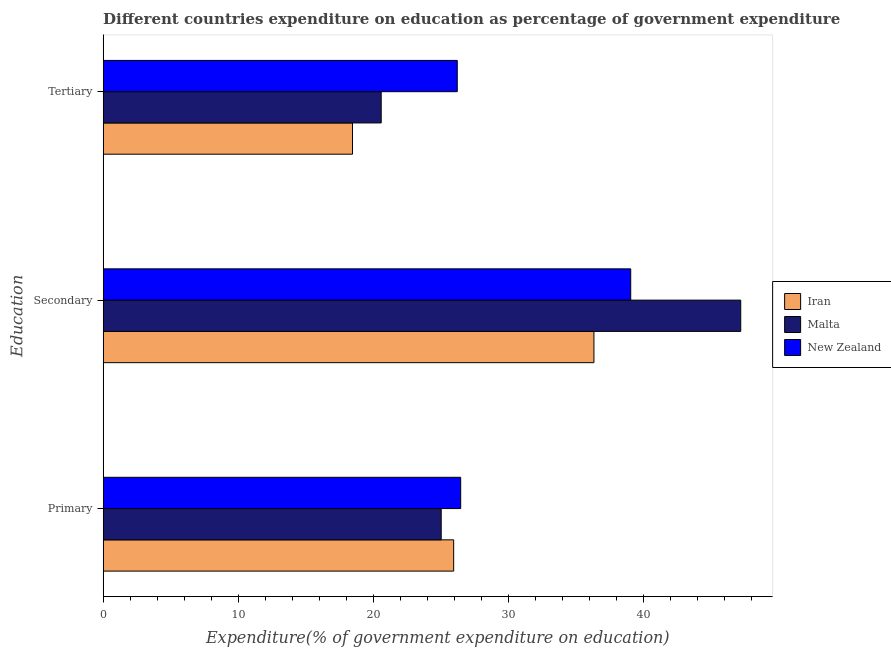How many different coloured bars are there?
Keep it short and to the point. 3. Are the number of bars on each tick of the Y-axis equal?
Your response must be concise. Yes. How many bars are there on the 2nd tick from the bottom?
Keep it short and to the point. 3. What is the label of the 3rd group of bars from the top?
Ensure brevity in your answer.  Primary. What is the expenditure on tertiary education in New Zealand?
Ensure brevity in your answer.  26.21. Across all countries, what is the maximum expenditure on primary education?
Provide a succinct answer. 26.47. Across all countries, what is the minimum expenditure on tertiary education?
Ensure brevity in your answer.  18.46. In which country was the expenditure on tertiary education maximum?
Make the answer very short. New Zealand. In which country was the expenditure on secondary education minimum?
Provide a succinct answer. Iran. What is the total expenditure on secondary education in the graph?
Your answer should be compact. 122.58. What is the difference between the expenditure on primary education in Malta and that in New Zealand?
Provide a succinct answer. -1.44. What is the difference between the expenditure on secondary education in New Zealand and the expenditure on primary education in Iran?
Offer a terse response. 13.11. What is the average expenditure on primary education per country?
Your response must be concise. 25.81. What is the difference between the expenditure on tertiary education and expenditure on primary education in New Zealand?
Provide a succinct answer. -0.25. In how many countries, is the expenditure on tertiary education greater than 14 %?
Give a very brief answer. 3. What is the ratio of the expenditure on primary education in Iran to that in New Zealand?
Your answer should be compact. 0.98. Is the expenditure on secondary education in New Zealand less than that in Iran?
Provide a short and direct response. No. Is the difference between the expenditure on tertiary education in Malta and New Zealand greater than the difference between the expenditure on primary education in Malta and New Zealand?
Your answer should be very brief. No. What is the difference between the highest and the second highest expenditure on secondary education?
Your response must be concise. 8.14. What is the difference between the highest and the lowest expenditure on tertiary education?
Ensure brevity in your answer.  7.76. Is the sum of the expenditure on tertiary education in Malta and Iran greater than the maximum expenditure on secondary education across all countries?
Make the answer very short. No. What does the 2nd bar from the top in Tertiary represents?
Your answer should be very brief. Malta. What does the 1st bar from the bottom in Secondary represents?
Ensure brevity in your answer.  Iran. How many bars are there?
Your response must be concise. 9. Are the values on the major ticks of X-axis written in scientific E-notation?
Make the answer very short. No. Does the graph contain any zero values?
Make the answer very short. No. Where does the legend appear in the graph?
Provide a short and direct response. Center right. What is the title of the graph?
Provide a succinct answer. Different countries expenditure on education as percentage of government expenditure. What is the label or title of the X-axis?
Ensure brevity in your answer.  Expenditure(% of government expenditure on education). What is the label or title of the Y-axis?
Your response must be concise. Education. What is the Expenditure(% of government expenditure on education) in Iran in Primary?
Provide a short and direct response. 25.95. What is the Expenditure(% of government expenditure on education) of Malta in Primary?
Ensure brevity in your answer.  25.02. What is the Expenditure(% of government expenditure on education) of New Zealand in Primary?
Your answer should be compact. 26.47. What is the Expenditure(% of government expenditure on education) in Iran in Secondary?
Offer a terse response. 36.33. What is the Expenditure(% of government expenditure on education) in Malta in Secondary?
Offer a very short reply. 47.2. What is the Expenditure(% of government expenditure on education) in New Zealand in Secondary?
Give a very brief answer. 39.05. What is the Expenditure(% of government expenditure on education) in Iran in Tertiary?
Ensure brevity in your answer.  18.46. What is the Expenditure(% of government expenditure on education) of Malta in Tertiary?
Provide a succinct answer. 20.58. What is the Expenditure(% of government expenditure on education) of New Zealand in Tertiary?
Your answer should be compact. 26.21. Across all Education, what is the maximum Expenditure(% of government expenditure on education) in Iran?
Provide a succinct answer. 36.33. Across all Education, what is the maximum Expenditure(% of government expenditure on education) in Malta?
Ensure brevity in your answer.  47.2. Across all Education, what is the maximum Expenditure(% of government expenditure on education) of New Zealand?
Give a very brief answer. 39.05. Across all Education, what is the minimum Expenditure(% of government expenditure on education) of Iran?
Give a very brief answer. 18.46. Across all Education, what is the minimum Expenditure(% of government expenditure on education) of Malta?
Make the answer very short. 20.58. Across all Education, what is the minimum Expenditure(% of government expenditure on education) of New Zealand?
Provide a short and direct response. 26.21. What is the total Expenditure(% of government expenditure on education) of Iran in the graph?
Offer a very short reply. 80.73. What is the total Expenditure(% of government expenditure on education) in Malta in the graph?
Provide a succinct answer. 92.8. What is the total Expenditure(% of government expenditure on education) of New Zealand in the graph?
Your answer should be very brief. 91.73. What is the difference between the Expenditure(% of government expenditure on education) in Iran in Primary and that in Secondary?
Provide a short and direct response. -10.38. What is the difference between the Expenditure(% of government expenditure on education) of Malta in Primary and that in Secondary?
Provide a short and direct response. -22.17. What is the difference between the Expenditure(% of government expenditure on education) in New Zealand in Primary and that in Secondary?
Make the answer very short. -12.59. What is the difference between the Expenditure(% of government expenditure on education) in Iran in Primary and that in Tertiary?
Make the answer very short. 7.49. What is the difference between the Expenditure(% of government expenditure on education) of Malta in Primary and that in Tertiary?
Your answer should be compact. 4.44. What is the difference between the Expenditure(% of government expenditure on education) in New Zealand in Primary and that in Tertiary?
Your response must be concise. 0.25. What is the difference between the Expenditure(% of government expenditure on education) of Iran in Secondary and that in Tertiary?
Your response must be concise. 17.87. What is the difference between the Expenditure(% of government expenditure on education) in Malta in Secondary and that in Tertiary?
Your answer should be compact. 26.61. What is the difference between the Expenditure(% of government expenditure on education) of New Zealand in Secondary and that in Tertiary?
Provide a succinct answer. 12.84. What is the difference between the Expenditure(% of government expenditure on education) of Iran in Primary and the Expenditure(% of government expenditure on education) of Malta in Secondary?
Ensure brevity in your answer.  -21.25. What is the difference between the Expenditure(% of government expenditure on education) in Iran in Primary and the Expenditure(% of government expenditure on education) in New Zealand in Secondary?
Ensure brevity in your answer.  -13.11. What is the difference between the Expenditure(% of government expenditure on education) of Malta in Primary and the Expenditure(% of government expenditure on education) of New Zealand in Secondary?
Provide a short and direct response. -14.03. What is the difference between the Expenditure(% of government expenditure on education) in Iran in Primary and the Expenditure(% of government expenditure on education) in Malta in Tertiary?
Your answer should be compact. 5.36. What is the difference between the Expenditure(% of government expenditure on education) of Iran in Primary and the Expenditure(% of government expenditure on education) of New Zealand in Tertiary?
Provide a short and direct response. -0.27. What is the difference between the Expenditure(% of government expenditure on education) in Malta in Primary and the Expenditure(% of government expenditure on education) in New Zealand in Tertiary?
Your response must be concise. -1.19. What is the difference between the Expenditure(% of government expenditure on education) in Iran in Secondary and the Expenditure(% of government expenditure on education) in Malta in Tertiary?
Make the answer very short. 15.75. What is the difference between the Expenditure(% of government expenditure on education) of Iran in Secondary and the Expenditure(% of government expenditure on education) of New Zealand in Tertiary?
Provide a succinct answer. 10.12. What is the difference between the Expenditure(% of government expenditure on education) in Malta in Secondary and the Expenditure(% of government expenditure on education) in New Zealand in Tertiary?
Your answer should be very brief. 20.98. What is the average Expenditure(% of government expenditure on education) of Iran per Education?
Give a very brief answer. 26.91. What is the average Expenditure(% of government expenditure on education) in Malta per Education?
Make the answer very short. 30.93. What is the average Expenditure(% of government expenditure on education) in New Zealand per Education?
Give a very brief answer. 30.58. What is the difference between the Expenditure(% of government expenditure on education) in Iran and Expenditure(% of government expenditure on education) in Malta in Primary?
Keep it short and to the point. 0.92. What is the difference between the Expenditure(% of government expenditure on education) in Iran and Expenditure(% of government expenditure on education) in New Zealand in Primary?
Offer a very short reply. -0.52. What is the difference between the Expenditure(% of government expenditure on education) of Malta and Expenditure(% of government expenditure on education) of New Zealand in Primary?
Give a very brief answer. -1.44. What is the difference between the Expenditure(% of government expenditure on education) in Iran and Expenditure(% of government expenditure on education) in Malta in Secondary?
Make the answer very short. -10.87. What is the difference between the Expenditure(% of government expenditure on education) in Iran and Expenditure(% of government expenditure on education) in New Zealand in Secondary?
Your answer should be very brief. -2.72. What is the difference between the Expenditure(% of government expenditure on education) in Malta and Expenditure(% of government expenditure on education) in New Zealand in Secondary?
Make the answer very short. 8.14. What is the difference between the Expenditure(% of government expenditure on education) of Iran and Expenditure(% of government expenditure on education) of Malta in Tertiary?
Your answer should be very brief. -2.12. What is the difference between the Expenditure(% of government expenditure on education) of Iran and Expenditure(% of government expenditure on education) of New Zealand in Tertiary?
Keep it short and to the point. -7.76. What is the difference between the Expenditure(% of government expenditure on education) in Malta and Expenditure(% of government expenditure on education) in New Zealand in Tertiary?
Offer a very short reply. -5.63. What is the ratio of the Expenditure(% of government expenditure on education) of Iran in Primary to that in Secondary?
Provide a short and direct response. 0.71. What is the ratio of the Expenditure(% of government expenditure on education) in Malta in Primary to that in Secondary?
Make the answer very short. 0.53. What is the ratio of the Expenditure(% of government expenditure on education) of New Zealand in Primary to that in Secondary?
Give a very brief answer. 0.68. What is the ratio of the Expenditure(% of government expenditure on education) in Iran in Primary to that in Tertiary?
Offer a very short reply. 1.41. What is the ratio of the Expenditure(% of government expenditure on education) in Malta in Primary to that in Tertiary?
Ensure brevity in your answer.  1.22. What is the ratio of the Expenditure(% of government expenditure on education) of New Zealand in Primary to that in Tertiary?
Give a very brief answer. 1.01. What is the ratio of the Expenditure(% of government expenditure on education) of Iran in Secondary to that in Tertiary?
Your response must be concise. 1.97. What is the ratio of the Expenditure(% of government expenditure on education) in Malta in Secondary to that in Tertiary?
Your answer should be very brief. 2.29. What is the ratio of the Expenditure(% of government expenditure on education) in New Zealand in Secondary to that in Tertiary?
Your response must be concise. 1.49. What is the difference between the highest and the second highest Expenditure(% of government expenditure on education) in Iran?
Offer a terse response. 10.38. What is the difference between the highest and the second highest Expenditure(% of government expenditure on education) in Malta?
Offer a very short reply. 22.17. What is the difference between the highest and the second highest Expenditure(% of government expenditure on education) of New Zealand?
Your response must be concise. 12.59. What is the difference between the highest and the lowest Expenditure(% of government expenditure on education) of Iran?
Offer a terse response. 17.87. What is the difference between the highest and the lowest Expenditure(% of government expenditure on education) in Malta?
Provide a short and direct response. 26.61. What is the difference between the highest and the lowest Expenditure(% of government expenditure on education) of New Zealand?
Offer a terse response. 12.84. 